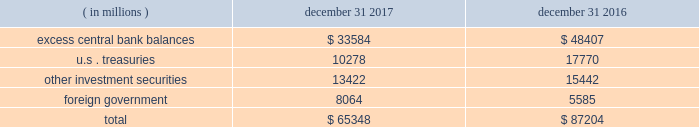Management 2019s discussion and analysis of financial condition and results of operations state street corporation | 89 $ 65.35 billion and $ 87.20 billion as of december 31 , 2017 and december 31 , 2016 , respectively .
Table 29 : components of average hqla by type of ( in millions ) december 31 , december 31 .
With respect to highly liquid short-term investments presented in the preceding table , due to the continued elevated level of client deposits as of december 31 , 2017 , we maintained cash balances in excess of regulatory requirements governing deposits with the federal reserve of approximately $ 33.58 billion at the federal reserve , the ecb and other non-u.s .
Central banks , compared to $ 48.40 billion as of december 31 , 2016 .
The lower levels of deposits with central banks as of december 31 , 2017 compared to december 31 , 2016 was due to normal deposit volatility .
Liquid securities carried in our asset liquidity include securities pledged without corresponding advances from the frbb , the fhlb , and other non- u.s .
Central banks .
State street bank is a member of the fhlb .
This membership allows for advances of liquidity in varying terms against high-quality collateral , which helps facilitate asset-and-liability management .
Access to primary , intra-day and contingent liquidity provided by these utilities is an important source of contingent liquidity with utilization subject to underlying conditions .
As of december 31 , 2017 and december 31 , 2016 , we had no outstanding primary credit borrowings from the frbb discount window or any other central bank facility , and as of the same dates , no fhlb advances were outstanding .
In addition to the securities included in our asset liquidity , we have significant amounts of other unencumbered investment securities .
The aggregate fair value of those securities was $ 66.10 billion as of december 31 , 2017 , compared to $ 54.40 billion as of december 31 , 2016 .
These securities are available sources of liquidity , although not as rapidly deployed as those included in our asset liquidity .
Measures of liquidity include lcr , nsfr and tlac which are described in "supervision and regulation" included under item 1 , business , of this form 10-k .
Uses of liquidity significant uses of our liquidity could result from the following : withdrawals of client deposits ; draw- downs of unfunded commitments to extend credit or to purchase securities , generally provided through lines of credit ; and short-duration advance facilities .
Such circumstances would generally arise under stress conditions including deterioration in credit ratings .
A recurring significant use of our liquidity involves our deployment of hqla from our investment portfolio to post collateral to financial institutions and participants in our agency lending program serving as sources of securities under our enhanced custody program .
We had unfunded commitments to extend credit with gross contractual amounts totaling $ 26.49 billion and $ 26.99 billion as of december 31 , 2017 and december 31 , 2016 , respectively .
These amounts do not reflect the value of any collateral .
As of december 31 , 2017 , approximately 72% ( 72 % ) of our unfunded commitments to extend credit expire within one year .
Since many of our commitments are expected to expire or renew without being drawn upon , the gross contractual amounts do not necessarily represent our future cash requirements .
Information about our resolution planning and the impact actions under our resolution plans could have on our liquidity is provided in "supervision and regulation" included under item 1 .
Business , of this form 10-k .
Funding deposits we provide products and services including custody , accounting , administration , daily pricing , foreign exchange services , cash management , financial asset management , securities finance and investment advisory services .
As a provider of these products and services , we generate client deposits , which have generally provided a stable , low-cost source of funds .
As a global custodian , clients place deposits with state street entities in various currencies .
As of december 31 , 2017 and december 31 , 2016 , approximately 60% ( 60 % ) of our average client deposit balances were denominated in u.s .
Dollars , approximately 20% ( 20 % ) in eur , 10% ( 10 % ) in gbp and 10% ( 10 % ) in all other currencies .
For the past several years , we have frequently experienced higher client deposit inflows toward the end of each fiscal quarter or the end of the fiscal year .
As a result , we believe average client deposit balances are more reflective of ongoing funding than period-end balances. .
What percent of total balance is the excess central bank balances in 2017? 
Computations: (33584 / 65348)
Answer: 0.51393. 